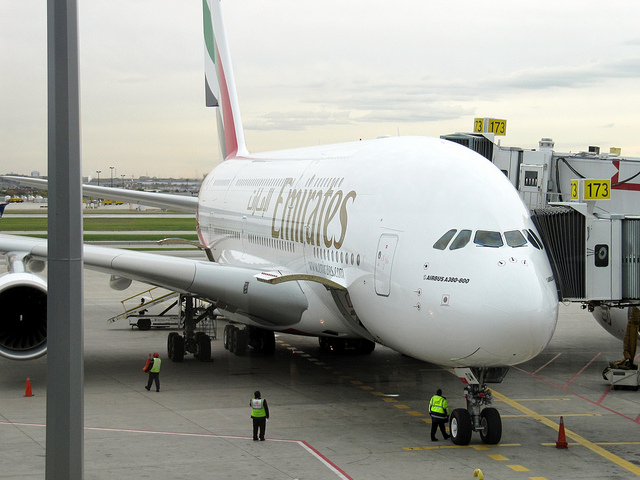Read and extract the text from this image. Emirates 173 173 3 173 